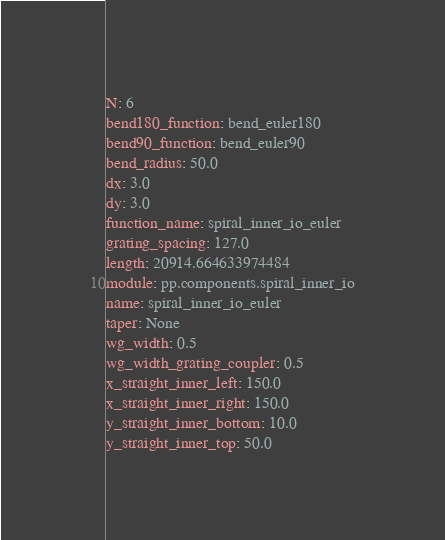<code> <loc_0><loc_0><loc_500><loc_500><_YAML_>N: 6
bend180_function: bend_euler180
bend90_function: bend_euler90
bend_radius: 50.0
dx: 3.0
dy: 3.0
function_name: spiral_inner_io_euler
grating_spacing: 127.0
length: 20914.664633974484
module: pp.components.spiral_inner_io
name: spiral_inner_io_euler
taper: None
wg_width: 0.5
wg_width_grating_coupler: 0.5
x_straight_inner_left: 150.0
x_straight_inner_right: 150.0
y_straight_inner_bottom: 10.0
y_straight_inner_top: 50.0
</code> 